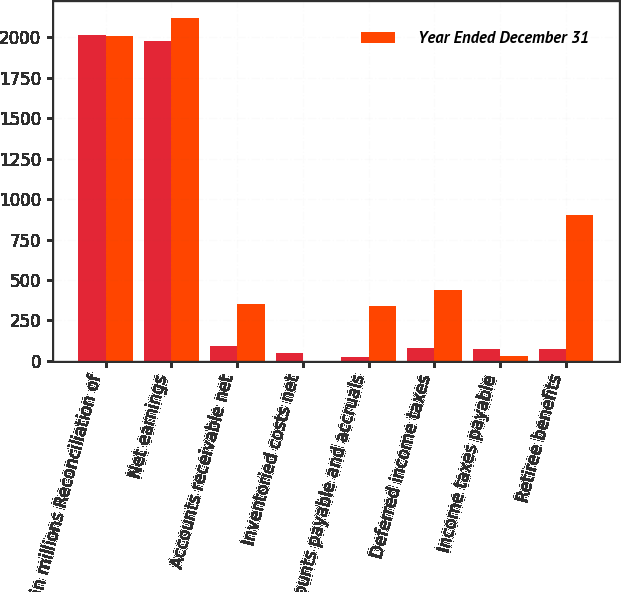Convert chart. <chart><loc_0><loc_0><loc_500><loc_500><stacked_bar_chart><ecel><fcel>in millions Reconciliation of<fcel>Net earnings<fcel>Accounts receivable net<fcel>Inventoried costs net<fcel>Accounts payable and accruals<fcel>Deferred income taxes<fcel>Income taxes payable<fcel>Retiree benefits<nl><fcel>nan<fcel>2012<fcel>1978<fcel>90<fcel>46<fcel>23<fcel>78<fcel>75<fcel>71<nl><fcel>Year Ended December 31<fcel>2011<fcel>2118<fcel>350<fcel>2<fcel>341<fcel>441<fcel>32<fcel>904<nl></chart> 